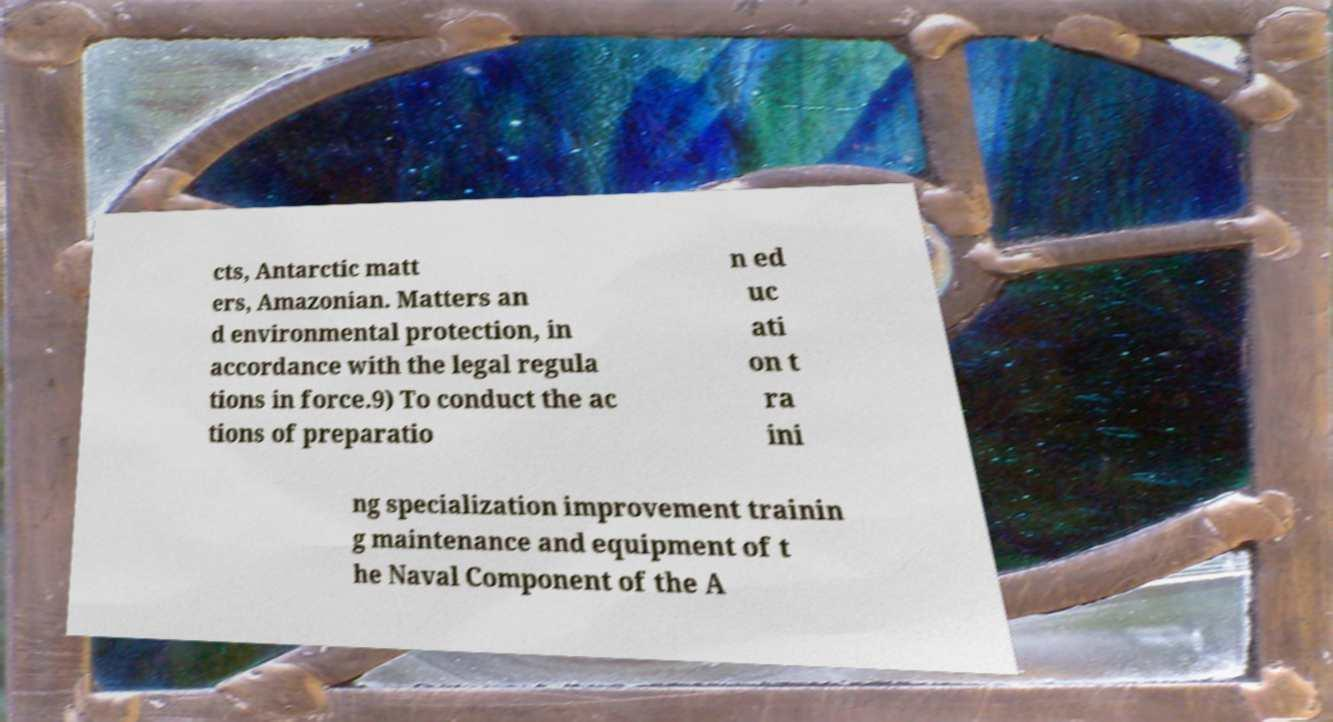I need the written content from this picture converted into text. Can you do that? cts, Antarctic matt ers, Amazonian. Matters an d environmental protection, in accordance with the legal regula tions in force.9) To conduct the ac tions of preparatio n ed uc ati on t ra ini ng specialization improvement trainin g maintenance and equipment of t he Naval Component of the A 